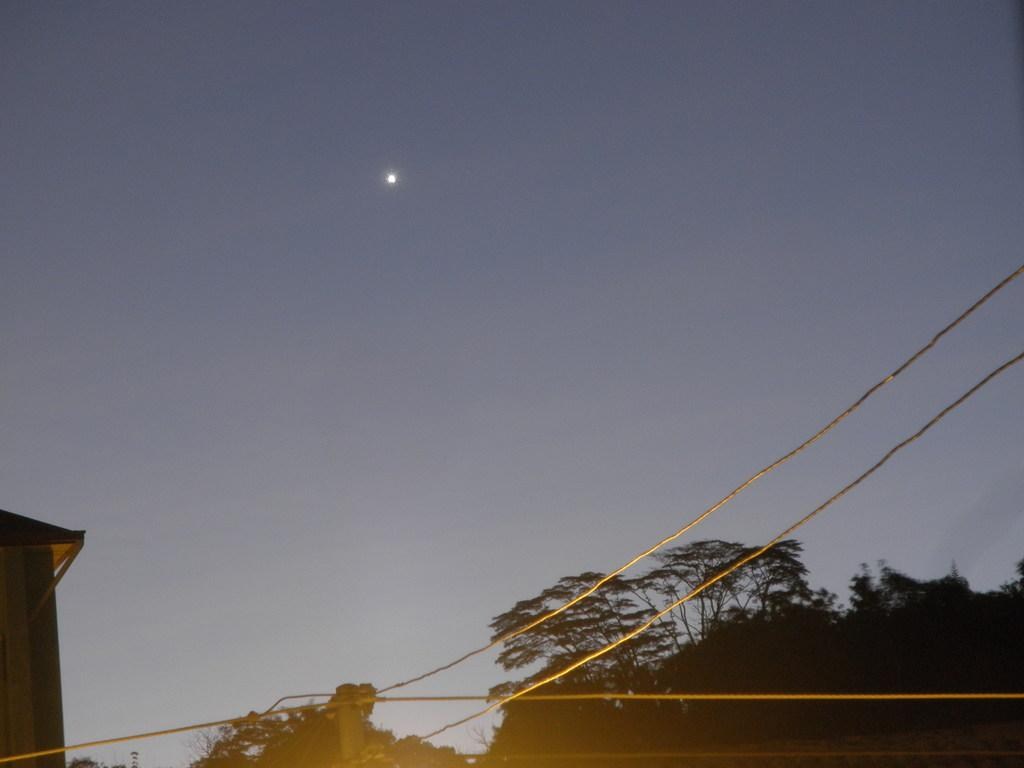What type of natural elements can be seen in the image? There are trees in the image. What man-made objects can be seen in the image? There are ropes and other objects in the image. What is visible at the top of the image? The sky is visible at the top of the image. What celestial body can be seen in the sky? The moon is visible in the sky. What type of pies are being baked in the image? There are no pies or baking activities present in the image. What type of fuel is being used to power the objects in the image? There is no information about fuel or power sources in the image. 